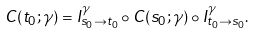Convert formula to latex. <formula><loc_0><loc_0><loc_500><loc_500>C ( t _ { 0 } ; \gamma ) = I ^ { \gamma } _ { s _ { 0 } \to t _ { 0 } } \circ C ( s _ { 0 } ; \gamma ) \circ I ^ { \gamma } _ { t _ { 0 } \to s _ { 0 } } .</formula> 